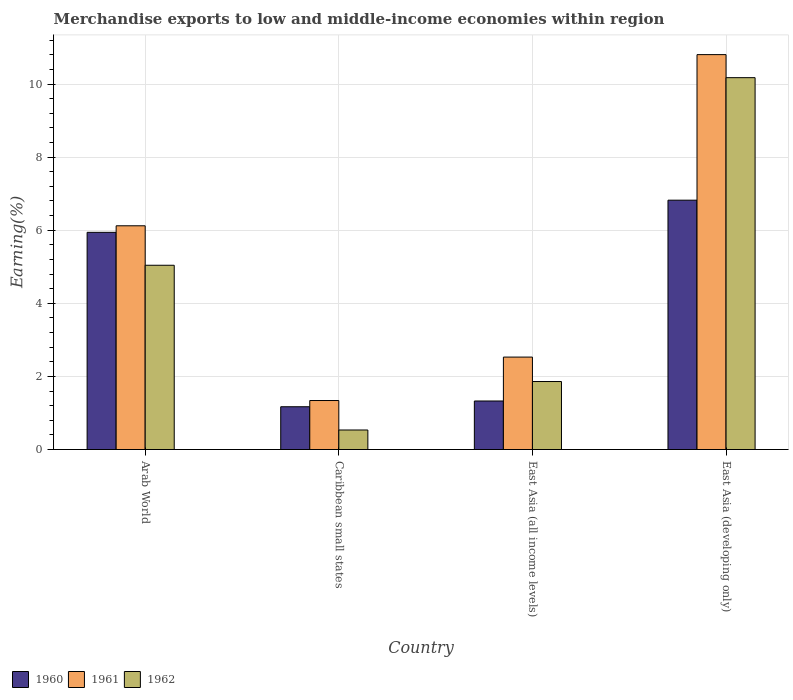How many groups of bars are there?
Give a very brief answer. 4. Are the number of bars on each tick of the X-axis equal?
Offer a terse response. Yes. How many bars are there on the 3rd tick from the left?
Offer a terse response. 3. How many bars are there on the 3rd tick from the right?
Your answer should be very brief. 3. What is the label of the 1st group of bars from the left?
Your answer should be compact. Arab World. What is the percentage of amount earned from merchandise exports in 1962 in East Asia (all income levels)?
Offer a terse response. 1.86. Across all countries, what is the maximum percentage of amount earned from merchandise exports in 1961?
Offer a very short reply. 10.8. Across all countries, what is the minimum percentage of amount earned from merchandise exports in 1960?
Give a very brief answer. 1.17. In which country was the percentage of amount earned from merchandise exports in 1960 maximum?
Your answer should be very brief. East Asia (developing only). In which country was the percentage of amount earned from merchandise exports in 1961 minimum?
Give a very brief answer. Caribbean small states. What is the total percentage of amount earned from merchandise exports in 1962 in the graph?
Offer a very short reply. 17.61. What is the difference between the percentage of amount earned from merchandise exports in 1960 in Arab World and that in East Asia (all income levels)?
Keep it short and to the point. 4.61. What is the difference between the percentage of amount earned from merchandise exports in 1961 in Arab World and the percentage of amount earned from merchandise exports in 1960 in Caribbean small states?
Provide a succinct answer. 4.95. What is the average percentage of amount earned from merchandise exports in 1960 per country?
Ensure brevity in your answer.  3.82. What is the difference between the percentage of amount earned from merchandise exports of/in 1961 and percentage of amount earned from merchandise exports of/in 1960 in Caribbean small states?
Make the answer very short. 0.17. In how many countries, is the percentage of amount earned from merchandise exports in 1962 greater than 8 %?
Your answer should be very brief. 1. What is the ratio of the percentage of amount earned from merchandise exports in 1961 in Arab World to that in East Asia (developing only)?
Offer a very short reply. 0.57. Is the percentage of amount earned from merchandise exports in 1962 in Arab World less than that in Caribbean small states?
Give a very brief answer. No. What is the difference between the highest and the second highest percentage of amount earned from merchandise exports in 1962?
Provide a succinct answer. -8.31. What is the difference between the highest and the lowest percentage of amount earned from merchandise exports in 1962?
Make the answer very short. 9.64. Is the sum of the percentage of amount earned from merchandise exports in 1960 in Caribbean small states and East Asia (all income levels) greater than the maximum percentage of amount earned from merchandise exports in 1962 across all countries?
Give a very brief answer. No. What does the 3rd bar from the left in Caribbean small states represents?
Your answer should be compact. 1962. How many bars are there?
Ensure brevity in your answer.  12. What is the difference between two consecutive major ticks on the Y-axis?
Make the answer very short. 2. Where does the legend appear in the graph?
Your answer should be compact. Bottom left. What is the title of the graph?
Offer a very short reply. Merchandise exports to low and middle-income economies within region. What is the label or title of the Y-axis?
Keep it short and to the point. Earning(%). What is the Earning(%) of 1960 in Arab World?
Provide a short and direct response. 5.94. What is the Earning(%) in 1961 in Arab World?
Give a very brief answer. 6.12. What is the Earning(%) in 1962 in Arab World?
Provide a succinct answer. 5.04. What is the Earning(%) of 1960 in Caribbean small states?
Ensure brevity in your answer.  1.17. What is the Earning(%) of 1961 in Caribbean small states?
Your response must be concise. 1.34. What is the Earning(%) in 1962 in Caribbean small states?
Offer a terse response. 0.53. What is the Earning(%) of 1960 in East Asia (all income levels)?
Provide a succinct answer. 1.33. What is the Earning(%) in 1961 in East Asia (all income levels)?
Make the answer very short. 2.53. What is the Earning(%) of 1962 in East Asia (all income levels)?
Offer a terse response. 1.86. What is the Earning(%) in 1960 in East Asia (developing only)?
Your answer should be very brief. 6.82. What is the Earning(%) in 1961 in East Asia (developing only)?
Your response must be concise. 10.8. What is the Earning(%) of 1962 in East Asia (developing only)?
Your response must be concise. 10.17. Across all countries, what is the maximum Earning(%) in 1960?
Your answer should be compact. 6.82. Across all countries, what is the maximum Earning(%) of 1961?
Keep it short and to the point. 10.8. Across all countries, what is the maximum Earning(%) of 1962?
Make the answer very short. 10.17. Across all countries, what is the minimum Earning(%) in 1960?
Your response must be concise. 1.17. Across all countries, what is the minimum Earning(%) in 1961?
Provide a short and direct response. 1.34. Across all countries, what is the minimum Earning(%) in 1962?
Provide a succinct answer. 0.53. What is the total Earning(%) in 1960 in the graph?
Provide a short and direct response. 15.26. What is the total Earning(%) of 1961 in the graph?
Offer a very short reply. 20.8. What is the total Earning(%) in 1962 in the graph?
Provide a short and direct response. 17.61. What is the difference between the Earning(%) of 1960 in Arab World and that in Caribbean small states?
Provide a succinct answer. 4.77. What is the difference between the Earning(%) of 1961 in Arab World and that in Caribbean small states?
Provide a succinct answer. 4.78. What is the difference between the Earning(%) of 1962 in Arab World and that in Caribbean small states?
Make the answer very short. 4.51. What is the difference between the Earning(%) of 1960 in Arab World and that in East Asia (all income levels)?
Your response must be concise. 4.61. What is the difference between the Earning(%) in 1961 in Arab World and that in East Asia (all income levels)?
Ensure brevity in your answer.  3.59. What is the difference between the Earning(%) in 1962 in Arab World and that in East Asia (all income levels)?
Your response must be concise. 3.18. What is the difference between the Earning(%) in 1960 in Arab World and that in East Asia (developing only)?
Offer a very short reply. -0.88. What is the difference between the Earning(%) in 1961 in Arab World and that in East Asia (developing only)?
Give a very brief answer. -4.68. What is the difference between the Earning(%) in 1962 in Arab World and that in East Asia (developing only)?
Offer a terse response. -5.13. What is the difference between the Earning(%) of 1960 in Caribbean small states and that in East Asia (all income levels)?
Keep it short and to the point. -0.16. What is the difference between the Earning(%) of 1961 in Caribbean small states and that in East Asia (all income levels)?
Offer a very short reply. -1.19. What is the difference between the Earning(%) of 1962 in Caribbean small states and that in East Asia (all income levels)?
Give a very brief answer. -1.33. What is the difference between the Earning(%) in 1960 in Caribbean small states and that in East Asia (developing only)?
Give a very brief answer. -5.65. What is the difference between the Earning(%) in 1961 in Caribbean small states and that in East Asia (developing only)?
Your answer should be compact. -9.46. What is the difference between the Earning(%) in 1962 in Caribbean small states and that in East Asia (developing only)?
Provide a succinct answer. -9.64. What is the difference between the Earning(%) of 1960 in East Asia (all income levels) and that in East Asia (developing only)?
Ensure brevity in your answer.  -5.49. What is the difference between the Earning(%) in 1961 in East Asia (all income levels) and that in East Asia (developing only)?
Offer a terse response. -8.28. What is the difference between the Earning(%) in 1962 in East Asia (all income levels) and that in East Asia (developing only)?
Provide a short and direct response. -8.31. What is the difference between the Earning(%) in 1960 in Arab World and the Earning(%) in 1961 in Caribbean small states?
Provide a short and direct response. 4.6. What is the difference between the Earning(%) of 1960 in Arab World and the Earning(%) of 1962 in Caribbean small states?
Give a very brief answer. 5.41. What is the difference between the Earning(%) in 1961 in Arab World and the Earning(%) in 1962 in Caribbean small states?
Provide a succinct answer. 5.59. What is the difference between the Earning(%) of 1960 in Arab World and the Earning(%) of 1961 in East Asia (all income levels)?
Your answer should be compact. 3.41. What is the difference between the Earning(%) in 1960 in Arab World and the Earning(%) in 1962 in East Asia (all income levels)?
Keep it short and to the point. 4.08. What is the difference between the Earning(%) of 1961 in Arab World and the Earning(%) of 1962 in East Asia (all income levels)?
Give a very brief answer. 4.26. What is the difference between the Earning(%) in 1960 in Arab World and the Earning(%) in 1961 in East Asia (developing only)?
Make the answer very short. -4.86. What is the difference between the Earning(%) in 1960 in Arab World and the Earning(%) in 1962 in East Asia (developing only)?
Your response must be concise. -4.23. What is the difference between the Earning(%) in 1961 in Arab World and the Earning(%) in 1962 in East Asia (developing only)?
Your response must be concise. -4.05. What is the difference between the Earning(%) of 1960 in Caribbean small states and the Earning(%) of 1961 in East Asia (all income levels)?
Provide a succinct answer. -1.36. What is the difference between the Earning(%) of 1960 in Caribbean small states and the Earning(%) of 1962 in East Asia (all income levels)?
Give a very brief answer. -0.69. What is the difference between the Earning(%) in 1961 in Caribbean small states and the Earning(%) in 1962 in East Asia (all income levels)?
Give a very brief answer. -0.52. What is the difference between the Earning(%) in 1960 in Caribbean small states and the Earning(%) in 1961 in East Asia (developing only)?
Ensure brevity in your answer.  -9.63. What is the difference between the Earning(%) of 1960 in Caribbean small states and the Earning(%) of 1962 in East Asia (developing only)?
Make the answer very short. -9. What is the difference between the Earning(%) of 1961 in Caribbean small states and the Earning(%) of 1962 in East Asia (developing only)?
Your response must be concise. -8.83. What is the difference between the Earning(%) of 1960 in East Asia (all income levels) and the Earning(%) of 1961 in East Asia (developing only)?
Your response must be concise. -9.48. What is the difference between the Earning(%) in 1960 in East Asia (all income levels) and the Earning(%) in 1962 in East Asia (developing only)?
Give a very brief answer. -8.85. What is the difference between the Earning(%) of 1961 in East Asia (all income levels) and the Earning(%) of 1962 in East Asia (developing only)?
Keep it short and to the point. -7.65. What is the average Earning(%) of 1960 per country?
Offer a very short reply. 3.82. What is the average Earning(%) of 1961 per country?
Give a very brief answer. 5.2. What is the average Earning(%) of 1962 per country?
Provide a short and direct response. 4.4. What is the difference between the Earning(%) in 1960 and Earning(%) in 1961 in Arab World?
Give a very brief answer. -0.18. What is the difference between the Earning(%) in 1960 and Earning(%) in 1962 in Arab World?
Make the answer very short. 0.9. What is the difference between the Earning(%) of 1961 and Earning(%) of 1962 in Arab World?
Your response must be concise. 1.08. What is the difference between the Earning(%) in 1960 and Earning(%) in 1961 in Caribbean small states?
Ensure brevity in your answer.  -0.17. What is the difference between the Earning(%) of 1960 and Earning(%) of 1962 in Caribbean small states?
Ensure brevity in your answer.  0.64. What is the difference between the Earning(%) of 1961 and Earning(%) of 1962 in Caribbean small states?
Your answer should be compact. 0.81. What is the difference between the Earning(%) of 1960 and Earning(%) of 1961 in East Asia (all income levels)?
Provide a succinct answer. -1.2. What is the difference between the Earning(%) in 1960 and Earning(%) in 1962 in East Asia (all income levels)?
Provide a succinct answer. -0.53. What is the difference between the Earning(%) in 1961 and Earning(%) in 1962 in East Asia (all income levels)?
Your answer should be compact. 0.67. What is the difference between the Earning(%) of 1960 and Earning(%) of 1961 in East Asia (developing only)?
Make the answer very short. -3.98. What is the difference between the Earning(%) of 1960 and Earning(%) of 1962 in East Asia (developing only)?
Ensure brevity in your answer.  -3.35. What is the difference between the Earning(%) of 1961 and Earning(%) of 1962 in East Asia (developing only)?
Offer a terse response. 0.63. What is the ratio of the Earning(%) of 1960 in Arab World to that in Caribbean small states?
Offer a terse response. 5.08. What is the ratio of the Earning(%) of 1961 in Arab World to that in Caribbean small states?
Your answer should be compact. 4.57. What is the ratio of the Earning(%) of 1962 in Arab World to that in Caribbean small states?
Your answer should be compact. 9.44. What is the ratio of the Earning(%) of 1960 in Arab World to that in East Asia (all income levels)?
Keep it short and to the point. 4.48. What is the ratio of the Earning(%) of 1961 in Arab World to that in East Asia (all income levels)?
Keep it short and to the point. 2.42. What is the ratio of the Earning(%) in 1962 in Arab World to that in East Asia (all income levels)?
Your answer should be compact. 2.71. What is the ratio of the Earning(%) of 1960 in Arab World to that in East Asia (developing only)?
Your answer should be compact. 0.87. What is the ratio of the Earning(%) of 1961 in Arab World to that in East Asia (developing only)?
Your response must be concise. 0.57. What is the ratio of the Earning(%) in 1962 in Arab World to that in East Asia (developing only)?
Your answer should be very brief. 0.5. What is the ratio of the Earning(%) of 1960 in Caribbean small states to that in East Asia (all income levels)?
Your answer should be very brief. 0.88. What is the ratio of the Earning(%) of 1961 in Caribbean small states to that in East Asia (all income levels)?
Offer a terse response. 0.53. What is the ratio of the Earning(%) in 1962 in Caribbean small states to that in East Asia (all income levels)?
Give a very brief answer. 0.29. What is the ratio of the Earning(%) in 1960 in Caribbean small states to that in East Asia (developing only)?
Offer a very short reply. 0.17. What is the ratio of the Earning(%) of 1961 in Caribbean small states to that in East Asia (developing only)?
Your answer should be compact. 0.12. What is the ratio of the Earning(%) in 1962 in Caribbean small states to that in East Asia (developing only)?
Offer a terse response. 0.05. What is the ratio of the Earning(%) in 1960 in East Asia (all income levels) to that in East Asia (developing only)?
Your response must be concise. 0.19. What is the ratio of the Earning(%) of 1961 in East Asia (all income levels) to that in East Asia (developing only)?
Make the answer very short. 0.23. What is the ratio of the Earning(%) of 1962 in East Asia (all income levels) to that in East Asia (developing only)?
Provide a succinct answer. 0.18. What is the difference between the highest and the second highest Earning(%) in 1960?
Offer a terse response. 0.88. What is the difference between the highest and the second highest Earning(%) of 1961?
Provide a short and direct response. 4.68. What is the difference between the highest and the second highest Earning(%) in 1962?
Your answer should be compact. 5.13. What is the difference between the highest and the lowest Earning(%) in 1960?
Ensure brevity in your answer.  5.65. What is the difference between the highest and the lowest Earning(%) in 1961?
Offer a very short reply. 9.46. What is the difference between the highest and the lowest Earning(%) of 1962?
Offer a terse response. 9.64. 